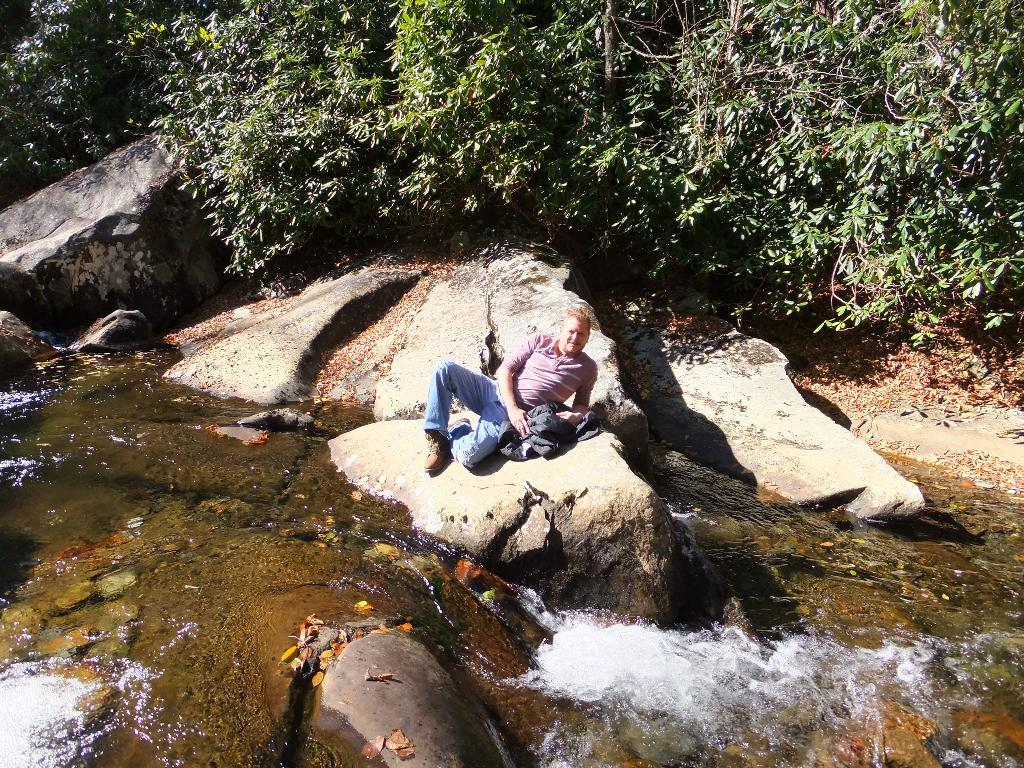What is the person in the image doing? The person is sitting on a rock in the image. What is in front of the person? There is floating water in front of the person. What can be seen in the background of the image? There are rocks and trees in the background of the image. What type of eggs can be seen in the design of the person's clothing in the image? There is no mention of eggs or any design on the person's clothing in the image. 